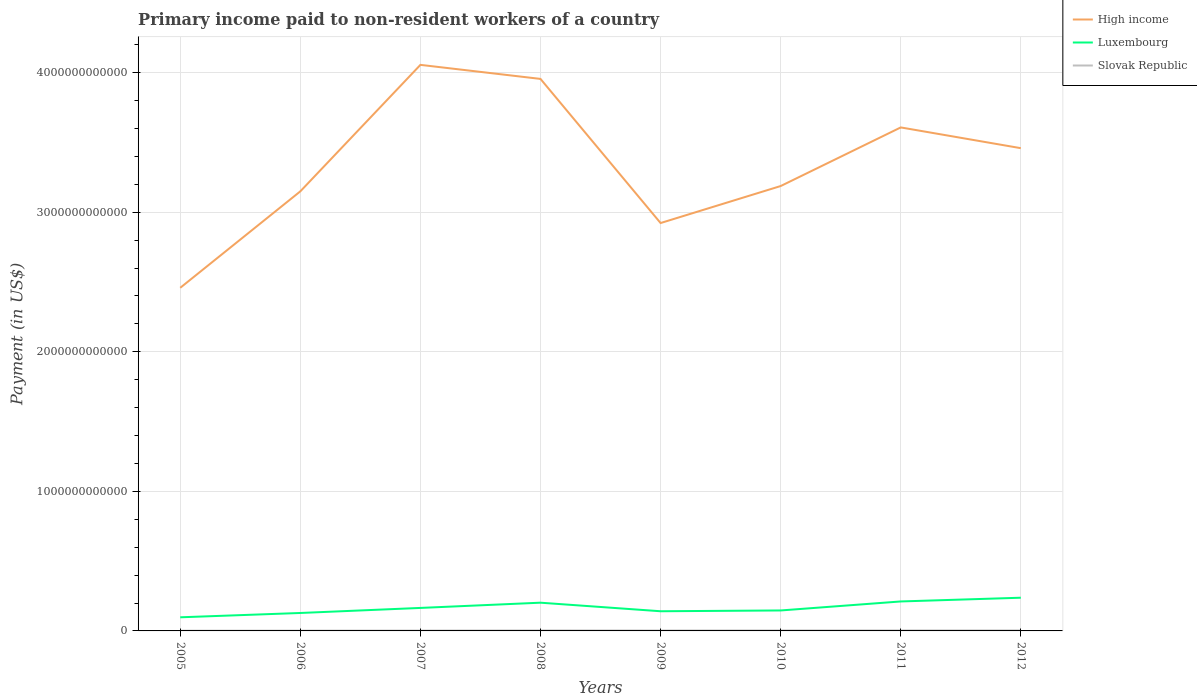Is the number of lines equal to the number of legend labels?
Ensure brevity in your answer.  Yes. Across all years, what is the maximum amount paid to workers in Slovak Republic?
Ensure brevity in your answer.  1.58e+09. What is the total amount paid to workers in Luxembourg in the graph?
Provide a succinct answer. -3.56e+1. What is the difference between the highest and the second highest amount paid to workers in High income?
Ensure brevity in your answer.  1.60e+12. How many years are there in the graph?
Ensure brevity in your answer.  8. What is the difference between two consecutive major ticks on the Y-axis?
Provide a short and direct response. 1.00e+12. Does the graph contain grids?
Give a very brief answer. Yes. What is the title of the graph?
Make the answer very short. Primary income paid to non-resident workers of a country. What is the label or title of the X-axis?
Your response must be concise. Years. What is the label or title of the Y-axis?
Provide a succinct answer. Payment (in US$). What is the Payment (in US$) of High income in 2005?
Offer a terse response. 2.46e+12. What is the Payment (in US$) in Luxembourg in 2005?
Give a very brief answer. 9.77e+1. What is the Payment (in US$) of Slovak Republic in 2005?
Keep it short and to the point. 1.58e+09. What is the Payment (in US$) in High income in 2006?
Provide a short and direct response. 3.15e+12. What is the Payment (in US$) of Luxembourg in 2006?
Provide a succinct answer. 1.29e+11. What is the Payment (in US$) in Slovak Republic in 2006?
Your answer should be very brief. 1.96e+09. What is the Payment (in US$) of High income in 2007?
Make the answer very short. 4.06e+12. What is the Payment (in US$) of Luxembourg in 2007?
Your answer should be very brief. 1.65e+11. What is the Payment (in US$) of Slovak Republic in 2007?
Offer a terse response. 2.34e+09. What is the Payment (in US$) of High income in 2008?
Keep it short and to the point. 3.95e+12. What is the Payment (in US$) in Luxembourg in 2008?
Your answer should be compact. 2.02e+11. What is the Payment (in US$) in Slovak Republic in 2008?
Your answer should be compact. 3.39e+09. What is the Payment (in US$) of High income in 2009?
Keep it short and to the point. 2.92e+12. What is the Payment (in US$) in Luxembourg in 2009?
Provide a succinct answer. 1.41e+11. What is the Payment (in US$) in Slovak Republic in 2009?
Provide a short and direct response. 2.74e+09. What is the Payment (in US$) in High income in 2010?
Your answer should be very brief. 3.19e+12. What is the Payment (in US$) in Luxembourg in 2010?
Keep it short and to the point. 1.47e+11. What is the Payment (in US$) of Slovak Republic in 2010?
Keep it short and to the point. 3.41e+09. What is the Payment (in US$) of High income in 2011?
Keep it short and to the point. 3.61e+12. What is the Payment (in US$) of Luxembourg in 2011?
Give a very brief answer. 2.11e+11. What is the Payment (in US$) of Slovak Republic in 2011?
Your answer should be compact. 3.36e+09. What is the Payment (in US$) in High income in 2012?
Provide a succinct answer. 3.46e+12. What is the Payment (in US$) of Luxembourg in 2012?
Ensure brevity in your answer.  2.38e+11. What is the Payment (in US$) in Slovak Republic in 2012?
Provide a succinct answer. 3.40e+09. Across all years, what is the maximum Payment (in US$) in High income?
Ensure brevity in your answer.  4.06e+12. Across all years, what is the maximum Payment (in US$) of Luxembourg?
Provide a succinct answer. 2.38e+11. Across all years, what is the maximum Payment (in US$) in Slovak Republic?
Your answer should be compact. 3.41e+09. Across all years, what is the minimum Payment (in US$) in High income?
Provide a short and direct response. 2.46e+12. Across all years, what is the minimum Payment (in US$) of Luxembourg?
Ensure brevity in your answer.  9.77e+1. Across all years, what is the minimum Payment (in US$) in Slovak Republic?
Provide a short and direct response. 1.58e+09. What is the total Payment (in US$) of High income in the graph?
Your answer should be compact. 2.68e+13. What is the total Payment (in US$) of Luxembourg in the graph?
Offer a very short reply. 1.33e+12. What is the total Payment (in US$) in Slovak Republic in the graph?
Provide a short and direct response. 2.22e+1. What is the difference between the Payment (in US$) in High income in 2005 and that in 2006?
Your answer should be very brief. -6.91e+11. What is the difference between the Payment (in US$) in Luxembourg in 2005 and that in 2006?
Your response must be concise. -3.09e+1. What is the difference between the Payment (in US$) of Slovak Republic in 2005 and that in 2006?
Offer a very short reply. -3.74e+08. What is the difference between the Payment (in US$) of High income in 2005 and that in 2007?
Provide a succinct answer. -1.60e+12. What is the difference between the Payment (in US$) of Luxembourg in 2005 and that in 2007?
Ensure brevity in your answer.  -6.71e+1. What is the difference between the Payment (in US$) of Slovak Republic in 2005 and that in 2007?
Make the answer very short. -7.55e+08. What is the difference between the Payment (in US$) in High income in 2005 and that in 2008?
Offer a terse response. -1.50e+12. What is the difference between the Payment (in US$) in Luxembourg in 2005 and that in 2008?
Keep it short and to the point. -1.05e+11. What is the difference between the Payment (in US$) in Slovak Republic in 2005 and that in 2008?
Keep it short and to the point. -1.81e+09. What is the difference between the Payment (in US$) in High income in 2005 and that in 2009?
Keep it short and to the point. -4.64e+11. What is the difference between the Payment (in US$) of Luxembourg in 2005 and that in 2009?
Provide a short and direct response. -4.33e+1. What is the difference between the Payment (in US$) of Slovak Republic in 2005 and that in 2009?
Your answer should be very brief. -1.16e+09. What is the difference between the Payment (in US$) of High income in 2005 and that in 2010?
Ensure brevity in your answer.  -7.29e+11. What is the difference between the Payment (in US$) in Luxembourg in 2005 and that in 2010?
Your answer should be compact. -4.89e+1. What is the difference between the Payment (in US$) in Slovak Republic in 2005 and that in 2010?
Give a very brief answer. -1.82e+09. What is the difference between the Payment (in US$) of High income in 2005 and that in 2011?
Your answer should be compact. -1.15e+12. What is the difference between the Payment (in US$) of Luxembourg in 2005 and that in 2011?
Make the answer very short. -1.13e+11. What is the difference between the Payment (in US$) in Slovak Republic in 2005 and that in 2011?
Your response must be concise. -1.78e+09. What is the difference between the Payment (in US$) in High income in 2005 and that in 2012?
Provide a succinct answer. -1.00e+12. What is the difference between the Payment (in US$) in Luxembourg in 2005 and that in 2012?
Provide a succinct answer. -1.40e+11. What is the difference between the Payment (in US$) in Slovak Republic in 2005 and that in 2012?
Make the answer very short. -1.82e+09. What is the difference between the Payment (in US$) in High income in 2006 and that in 2007?
Provide a succinct answer. -9.06e+11. What is the difference between the Payment (in US$) of Luxembourg in 2006 and that in 2007?
Offer a very short reply. -3.62e+1. What is the difference between the Payment (in US$) of Slovak Republic in 2006 and that in 2007?
Provide a succinct answer. -3.81e+08. What is the difference between the Payment (in US$) of High income in 2006 and that in 2008?
Offer a terse response. -8.06e+11. What is the difference between the Payment (in US$) in Luxembourg in 2006 and that in 2008?
Make the answer very short. -7.37e+1. What is the difference between the Payment (in US$) of Slovak Republic in 2006 and that in 2008?
Keep it short and to the point. -1.43e+09. What is the difference between the Payment (in US$) in High income in 2006 and that in 2009?
Your answer should be compact. 2.27e+11. What is the difference between the Payment (in US$) in Luxembourg in 2006 and that in 2009?
Provide a short and direct response. -1.24e+1. What is the difference between the Payment (in US$) of Slovak Republic in 2006 and that in 2009?
Keep it short and to the point. -7.85e+08. What is the difference between the Payment (in US$) in High income in 2006 and that in 2010?
Your response must be concise. -3.80e+1. What is the difference between the Payment (in US$) of Luxembourg in 2006 and that in 2010?
Your answer should be compact. -1.80e+1. What is the difference between the Payment (in US$) of Slovak Republic in 2006 and that in 2010?
Your response must be concise. -1.45e+09. What is the difference between the Payment (in US$) of High income in 2006 and that in 2011?
Give a very brief answer. -4.58e+11. What is the difference between the Payment (in US$) of Luxembourg in 2006 and that in 2011?
Offer a very short reply. -8.26e+1. What is the difference between the Payment (in US$) of Slovak Republic in 2006 and that in 2011?
Offer a very short reply. -1.40e+09. What is the difference between the Payment (in US$) in High income in 2006 and that in 2012?
Give a very brief answer. -3.09e+11. What is the difference between the Payment (in US$) of Luxembourg in 2006 and that in 2012?
Make the answer very short. -1.09e+11. What is the difference between the Payment (in US$) in Slovak Republic in 2006 and that in 2012?
Your answer should be compact. -1.44e+09. What is the difference between the Payment (in US$) of High income in 2007 and that in 2008?
Offer a very short reply. 1.01e+11. What is the difference between the Payment (in US$) of Luxembourg in 2007 and that in 2008?
Your response must be concise. -3.75e+1. What is the difference between the Payment (in US$) of Slovak Republic in 2007 and that in 2008?
Provide a succinct answer. -1.05e+09. What is the difference between the Payment (in US$) in High income in 2007 and that in 2009?
Provide a succinct answer. 1.13e+12. What is the difference between the Payment (in US$) in Luxembourg in 2007 and that in 2009?
Your answer should be compact. 2.38e+1. What is the difference between the Payment (in US$) in Slovak Republic in 2007 and that in 2009?
Your answer should be very brief. -4.04e+08. What is the difference between the Payment (in US$) of High income in 2007 and that in 2010?
Offer a very short reply. 8.68e+11. What is the difference between the Payment (in US$) of Luxembourg in 2007 and that in 2010?
Your answer should be compact. 1.82e+1. What is the difference between the Payment (in US$) of Slovak Republic in 2007 and that in 2010?
Keep it short and to the point. -1.07e+09. What is the difference between the Payment (in US$) of High income in 2007 and that in 2011?
Your response must be concise. 4.48e+11. What is the difference between the Payment (in US$) in Luxembourg in 2007 and that in 2011?
Your answer should be very brief. -4.64e+1. What is the difference between the Payment (in US$) in Slovak Republic in 2007 and that in 2011?
Your response must be concise. -1.02e+09. What is the difference between the Payment (in US$) in High income in 2007 and that in 2012?
Provide a short and direct response. 5.97e+11. What is the difference between the Payment (in US$) in Luxembourg in 2007 and that in 2012?
Provide a succinct answer. -7.31e+1. What is the difference between the Payment (in US$) of Slovak Republic in 2007 and that in 2012?
Your answer should be compact. -1.06e+09. What is the difference between the Payment (in US$) in High income in 2008 and that in 2009?
Offer a terse response. 1.03e+12. What is the difference between the Payment (in US$) in Luxembourg in 2008 and that in 2009?
Offer a very short reply. 6.13e+1. What is the difference between the Payment (in US$) of Slovak Republic in 2008 and that in 2009?
Provide a short and direct response. 6.49e+08. What is the difference between the Payment (in US$) in High income in 2008 and that in 2010?
Your response must be concise. 7.68e+11. What is the difference between the Payment (in US$) in Luxembourg in 2008 and that in 2010?
Provide a succinct answer. 5.56e+1. What is the difference between the Payment (in US$) in Slovak Republic in 2008 and that in 2010?
Give a very brief answer. -1.33e+07. What is the difference between the Payment (in US$) in High income in 2008 and that in 2011?
Offer a terse response. 3.48e+11. What is the difference between the Payment (in US$) in Luxembourg in 2008 and that in 2011?
Offer a very short reply. -8.90e+09. What is the difference between the Payment (in US$) in Slovak Republic in 2008 and that in 2011?
Provide a succinct answer. 2.89e+07. What is the difference between the Payment (in US$) of High income in 2008 and that in 2012?
Ensure brevity in your answer.  4.96e+11. What is the difference between the Payment (in US$) in Luxembourg in 2008 and that in 2012?
Offer a very short reply. -3.56e+1. What is the difference between the Payment (in US$) of Slovak Republic in 2008 and that in 2012?
Ensure brevity in your answer.  -1.11e+07. What is the difference between the Payment (in US$) of High income in 2009 and that in 2010?
Provide a short and direct response. -2.65e+11. What is the difference between the Payment (in US$) in Luxembourg in 2009 and that in 2010?
Keep it short and to the point. -5.64e+09. What is the difference between the Payment (in US$) of Slovak Republic in 2009 and that in 2010?
Ensure brevity in your answer.  -6.62e+08. What is the difference between the Payment (in US$) in High income in 2009 and that in 2011?
Provide a succinct answer. -6.85e+11. What is the difference between the Payment (in US$) in Luxembourg in 2009 and that in 2011?
Your answer should be compact. -7.02e+1. What is the difference between the Payment (in US$) in Slovak Republic in 2009 and that in 2011?
Your response must be concise. -6.20e+08. What is the difference between the Payment (in US$) in High income in 2009 and that in 2012?
Offer a terse response. -5.36e+11. What is the difference between the Payment (in US$) of Luxembourg in 2009 and that in 2012?
Ensure brevity in your answer.  -9.69e+1. What is the difference between the Payment (in US$) in Slovak Republic in 2009 and that in 2012?
Keep it short and to the point. -6.60e+08. What is the difference between the Payment (in US$) of High income in 2010 and that in 2011?
Provide a short and direct response. -4.20e+11. What is the difference between the Payment (in US$) in Luxembourg in 2010 and that in 2011?
Keep it short and to the point. -6.46e+1. What is the difference between the Payment (in US$) of Slovak Republic in 2010 and that in 2011?
Your answer should be very brief. 4.22e+07. What is the difference between the Payment (in US$) in High income in 2010 and that in 2012?
Make the answer very short. -2.71e+11. What is the difference between the Payment (in US$) of Luxembourg in 2010 and that in 2012?
Keep it short and to the point. -9.12e+1. What is the difference between the Payment (in US$) of Slovak Republic in 2010 and that in 2012?
Ensure brevity in your answer.  2.24e+06. What is the difference between the Payment (in US$) of High income in 2011 and that in 2012?
Make the answer very short. 1.49e+11. What is the difference between the Payment (in US$) of Luxembourg in 2011 and that in 2012?
Offer a terse response. -2.67e+1. What is the difference between the Payment (in US$) of Slovak Republic in 2011 and that in 2012?
Offer a very short reply. -4.00e+07. What is the difference between the Payment (in US$) of High income in 2005 and the Payment (in US$) of Luxembourg in 2006?
Your response must be concise. 2.33e+12. What is the difference between the Payment (in US$) in High income in 2005 and the Payment (in US$) in Slovak Republic in 2006?
Offer a terse response. 2.46e+12. What is the difference between the Payment (in US$) in Luxembourg in 2005 and the Payment (in US$) in Slovak Republic in 2006?
Keep it short and to the point. 9.57e+1. What is the difference between the Payment (in US$) of High income in 2005 and the Payment (in US$) of Luxembourg in 2007?
Provide a succinct answer. 2.29e+12. What is the difference between the Payment (in US$) of High income in 2005 and the Payment (in US$) of Slovak Republic in 2007?
Your answer should be compact. 2.46e+12. What is the difference between the Payment (in US$) in Luxembourg in 2005 and the Payment (in US$) in Slovak Republic in 2007?
Give a very brief answer. 9.53e+1. What is the difference between the Payment (in US$) in High income in 2005 and the Payment (in US$) in Luxembourg in 2008?
Offer a terse response. 2.26e+12. What is the difference between the Payment (in US$) of High income in 2005 and the Payment (in US$) of Slovak Republic in 2008?
Offer a terse response. 2.45e+12. What is the difference between the Payment (in US$) in Luxembourg in 2005 and the Payment (in US$) in Slovak Republic in 2008?
Ensure brevity in your answer.  9.43e+1. What is the difference between the Payment (in US$) of High income in 2005 and the Payment (in US$) of Luxembourg in 2009?
Offer a very short reply. 2.32e+12. What is the difference between the Payment (in US$) of High income in 2005 and the Payment (in US$) of Slovak Republic in 2009?
Provide a short and direct response. 2.46e+12. What is the difference between the Payment (in US$) in Luxembourg in 2005 and the Payment (in US$) in Slovak Republic in 2009?
Your response must be concise. 9.49e+1. What is the difference between the Payment (in US$) in High income in 2005 and the Payment (in US$) in Luxembourg in 2010?
Keep it short and to the point. 2.31e+12. What is the difference between the Payment (in US$) in High income in 2005 and the Payment (in US$) in Slovak Republic in 2010?
Offer a terse response. 2.45e+12. What is the difference between the Payment (in US$) in Luxembourg in 2005 and the Payment (in US$) in Slovak Republic in 2010?
Your answer should be compact. 9.43e+1. What is the difference between the Payment (in US$) in High income in 2005 and the Payment (in US$) in Luxembourg in 2011?
Make the answer very short. 2.25e+12. What is the difference between the Payment (in US$) of High income in 2005 and the Payment (in US$) of Slovak Republic in 2011?
Make the answer very short. 2.45e+12. What is the difference between the Payment (in US$) of Luxembourg in 2005 and the Payment (in US$) of Slovak Republic in 2011?
Make the answer very short. 9.43e+1. What is the difference between the Payment (in US$) in High income in 2005 and the Payment (in US$) in Luxembourg in 2012?
Ensure brevity in your answer.  2.22e+12. What is the difference between the Payment (in US$) in High income in 2005 and the Payment (in US$) in Slovak Republic in 2012?
Provide a succinct answer. 2.45e+12. What is the difference between the Payment (in US$) in Luxembourg in 2005 and the Payment (in US$) in Slovak Republic in 2012?
Offer a terse response. 9.43e+1. What is the difference between the Payment (in US$) in High income in 2006 and the Payment (in US$) in Luxembourg in 2007?
Give a very brief answer. 2.98e+12. What is the difference between the Payment (in US$) in High income in 2006 and the Payment (in US$) in Slovak Republic in 2007?
Give a very brief answer. 3.15e+12. What is the difference between the Payment (in US$) in Luxembourg in 2006 and the Payment (in US$) in Slovak Republic in 2007?
Your answer should be very brief. 1.26e+11. What is the difference between the Payment (in US$) in High income in 2006 and the Payment (in US$) in Luxembourg in 2008?
Your answer should be compact. 2.95e+12. What is the difference between the Payment (in US$) in High income in 2006 and the Payment (in US$) in Slovak Republic in 2008?
Ensure brevity in your answer.  3.15e+12. What is the difference between the Payment (in US$) of Luxembourg in 2006 and the Payment (in US$) of Slovak Republic in 2008?
Your answer should be very brief. 1.25e+11. What is the difference between the Payment (in US$) of High income in 2006 and the Payment (in US$) of Luxembourg in 2009?
Keep it short and to the point. 3.01e+12. What is the difference between the Payment (in US$) in High income in 2006 and the Payment (in US$) in Slovak Republic in 2009?
Your answer should be very brief. 3.15e+12. What is the difference between the Payment (in US$) of Luxembourg in 2006 and the Payment (in US$) of Slovak Republic in 2009?
Provide a short and direct response. 1.26e+11. What is the difference between the Payment (in US$) in High income in 2006 and the Payment (in US$) in Luxembourg in 2010?
Your response must be concise. 3.00e+12. What is the difference between the Payment (in US$) of High income in 2006 and the Payment (in US$) of Slovak Republic in 2010?
Provide a succinct answer. 3.15e+12. What is the difference between the Payment (in US$) in Luxembourg in 2006 and the Payment (in US$) in Slovak Republic in 2010?
Provide a succinct answer. 1.25e+11. What is the difference between the Payment (in US$) in High income in 2006 and the Payment (in US$) in Luxembourg in 2011?
Give a very brief answer. 2.94e+12. What is the difference between the Payment (in US$) in High income in 2006 and the Payment (in US$) in Slovak Republic in 2011?
Make the answer very short. 3.15e+12. What is the difference between the Payment (in US$) of Luxembourg in 2006 and the Payment (in US$) of Slovak Republic in 2011?
Provide a succinct answer. 1.25e+11. What is the difference between the Payment (in US$) in High income in 2006 and the Payment (in US$) in Luxembourg in 2012?
Your response must be concise. 2.91e+12. What is the difference between the Payment (in US$) in High income in 2006 and the Payment (in US$) in Slovak Republic in 2012?
Your answer should be compact. 3.15e+12. What is the difference between the Payment (in US$) of Luxembourg in 2006 and the Payment (in US$) of Slovak Republic in 2012?
Ensure brevity in your answer.  1.25e+11. What is the difference between the Payment (in US$) of High income in 2007 and the Payment (in US$) of Luxembourg in 2008?
Keep it short and to the point. 3.85e+12. What is the difference between the Payment (in US$) of High income in 2007 and the Payment (in US$) of Slovak Republic in 2008?
Your answer should be very brief. 4.05e+12. What is the difference between the Payment (in US$) of Luxembourg in 2007 and the Payment (in US$) of Slovak Republic in 2008?
Offer a terse response. 1.61e+11. What is the difference between the Payment (in US$) in High income in 2007 and the Payment (in US$) in Luxembourg in 2009?
Make the answer very short. 3.91e+12. What is the difference between the Payment (in US$) in High income in 2007 and the Payment (in US$) in Slovak Republic in 2009?
Offer a terse response. 4.05e+12. What is the difference between the Payment (in US$) of Luxembourg in 2007 and the Payment (in US$) of Slovak Republic in 2009?
Your response must be concise. 1.62e+11. What is the difference between the Payment (in US$) in High income in 2007 and the Payment (in US$) in Luxembourg in 2010?
Provide a short and direct response. 3.91e+12. What is the difference between the Payment (in US$) of High income in 2007 and the Payment (in US$) of Slovak Republic in 2010?
Offer a terse response. 4.05e+12. What is the difference between the Payment (in US$) of Luxembourg in 2007 and the Payment (in US$) of Slovak Republic in 2010?
Your response must be concise. 1.61e+11. What is the difference between the Payment (in US$) in High income in 2007 and the Payment (in US$) in Luxembourg in 2011?
Provide a short and direct response. 3.84e+12. What is the difference between the Payment (in US$) of High income in 2007 and the Payment (in US$) of Slovak Republic in 2011?
Ensure brevity in your answer.  4.05e+12. What is the difference between the Payment (in US$) in Luxembourg in 2007 and the Payment (in US$) in Slovak Republic in 2011?
Your answer should be compact. 1.61e+11. What is the difference between the Payment (in US$) of High income in 2007 and the Payment (in US$) of Luxembourg in 2012?
Make the answer very short. 3.82e+12. What is the difference between the Payment (in US$) of High income in 2007 and the Payment (in US$) of Slovak Republic in 2012?
Ensure brevity in your answer.  4.05e+12. What is the difference between the Payment (in US$) of Luxembourg in 2007 and the Payment (in US$) of Slovak Republic in 2012?
Offer a terse response. 1.61e+11. What is the difference between the Payment (in US$) in High income in 2008 and the Payment (in US$) in Luxembourg in 2009?
Your answer should be very brief. 3.81e+12. What is the difference between the Payment (in US$) in High income in 2008 and the Payment (in US$) in Slovak Republic in 2009?
Your answer should be compact. 3.95e+12. What is the difference between the Payment (in US$) in Luxembourg in 2008 and the Payment (in US$) in Slovak Republic in 2009?
Offer a very short reply. 1.99e+11. What is the difference between the Payment (in US$) of High income in 2008 and the Payment (in US$) of Luxembourg in 2010?
Make the answer very short. 3.81e+12. What is the difference between the Payment (in US$) of High income in 2008 and the Payment (in US$) of Slovak Republic in 2010?
Ensure brevity in your answer.  3.95e+12. What is the difference between the Payment (in US$) in Luxembourg in 2008 and the Payment (in US$) in Slovak Republic in 2010?
Keep it short and to the point. 1.99e+11. What is the difference between the Payment (in US$) in High income in 2008 and the Payment (in US$) in Luxembourg in 2011?
Provide a short and direct response. 3.74e+12. What is the difference between the Payment (in US$) in High income in 2008 and the Payment (in US$) in Slovak Republic in 2011?
Give a very brief answer. 3.95e+12. What is the difference between the Payment (in US$) in Luxembourg in 2008 and the Payment (in US$) in Slovak Republic in 2011?
Your answer should be compact. 1.99e+11. What is the difference between the Payment (in US$) of High income in 2008 and the Payment (in US$) of Luxembourg in 2012?
Give a very brief answer. 3.72e+12. What is the difference between the Payment (in US$) of High income in 2008 and the Payment (in US$) of Slovak Republic in 2012?
Offer a very short reply. 3.95e+12. What is the difference between the Payment (in US$) of Luxembourg in 2008 and the Payment (in US$) of Slovak Republic in 2012?
Keep it short and to the point. 1.99e+11. What is the difference between the Payment (in US$) in High income in 2009 and the Payment (in US$) in Luxembourg in 2010?
Your response must be concise. 2.78e+12. What is the difference between the Payment (in US$) of High income in 2009 and the Payment (in US$) of Slovak Republic in 2010?
Make the answer very short. 2.92e+12. What is the difference between the Payment (in US$) in Luxembourg in 2009 and the Payment (in US$) in Slovak Republic in 2010?
Keep it short and to the point. 1.38e+11. What is the difference between the Payment (in US$) in High income in 2009 and the Payment (in US$) in Luxembourg in 2011?
Offer a terse response. 2.71e+12. What is the difference between the Payment (in US$) of High income in 2009 and the Payment (in US$) of Slovak Republic in 2011?
Your answer should be compact. 2.92e+12. What is the difference between the Payment (in US$) of Luxembourg in 2009 and the Payment (in US$) of Slovak Republic in 2011?
Your answer should be very brief. 1.38e+11. What is the difference between the Payment (in US$) in High income in 2009 and the Payment (in US$) in Luxembourg in 2012?
Offer a terse response. 2.68e+12. What is the difference between the Payment (in US$) of High income in 2009 and the Payment (in US$) of Slovak Republic in 2012?
Your answer should be very brief. 2.92e+12. What is the difference between the Payment (in US$) in Luxembourg in 2009 and the Payment (in US$) in Slovak Republic in 2012?
Your answer should be very brief. 1.38e+11. What is the difference between the Payment (in US$) of High income in 2010 and the Payment (in US$) of Luxembourg in 2011?
Your answer should be compact. 2.98e+12. What is the difference between the Payment (in US$) of High income in 2010 and the Payment (in US$) of Slovak Republic in 2011?
Your answer should be very brief. 3.18e+12. What is the difference between the Payment (in US$) of Luxembourg in 2010 and the Payment (in US$) of Slovak Republic in 2011?
Provide a short and direct response. 1.43e+11. What is the difference between the Payment (in US$) in High income in 2010 and the Payment (in US$) in Luxembourg in 2012?
Offer a very short reply. 2.95e+12. What is the difference between the Payment (in US$) in High income in 2010 and the Payment (in US$) in Slovak Republic in 2012?
Your answer should be compact. 3.18e+12. What is the difference between the Payment (in US$) of Luxembourg in 2010 and the Payment (in US$) of Slovak Republic in 2012?
Give a very brief answer. 1.43e+11. What is the difference between the Payment (in US$) in High income in 2011 and the Payment (in US$) in Luxembourg in 2012?
Ensure brevity in your answer.  3.37e+12. What is the difference between the Payment (in US$) in High income in 2011 and the Payment (in US$) in Slovak Republic in 2012?
Give a very brief answer. 3.60e+12. What is the difference between the Payment (in US$) in Luxembourg in 2011 and the Payment (in US$) in Slovak Republic in 2012?
Offer a terse response. 2.08e+11. What is the average Payment (in US$) in High income per year?
Ensure brevity in your answer.  3.35e+12. What is the average Payment (in US$) in Luxembourg per year?
Offer a very short reply. 1.66e+11. What is the average Payment (in US$) in Slovak Republic per year?
Offer a very short reply. 2.77e+09. In the year 2005, what is the difference between the Payment (in US$) in High income and Payment (in US$) in Luxembourg?
Ensure brevity in your answer.  2.36e+12. In the year 2005, what is the difference between the Payment (in US$) in High income and Payment (in US$) in Slovak Republic?
Offer a very short reply. 2.46e+12. In the year 2005, what is the difference between the Payment (in US$) in Luxembourg and Payment (in US$) in Slovak Republic?
Your answer should be very brief. 9.61e+1. In the year 2006, what is the difference between the Payment (in US$) in High income and Payment (in US$) in Luxembourg?
Ensure brevity in your answer.  3.02e+12. In the year 2006, what is the difference between the Payment (in US$) of High income and Payment (in US$) of Slovak Republic?
Ensure brevity in your answer.  3.15e+12. In the year 2006, what is the difference between the Payment (in US$) in Luxembourg and Payment (in US$) in Slovak Republic?
Your answer should be very brief. 1.27e+11. In the year 2007, what is the difference between the Payment (in US$) of High income and Payment (in US$) of Luxembourg?
Offer a terse response. 3.89e+12. In the year 2007, what is the difference between the Payment (in US$) in High income and Payment (in US$) in Slovak Republic?
Ensure brevity in your answer.  4.05e+12. In the year 2007, what is the difference between the Payment (in US$) in Luxembourg and Payment (in US$) in Slovak Republic?
Provide a short and direct response. 1.62e+11. In the year 2008, what is the difference between the Payment (in US$) of High income and Payment (in US$) of Luxembourg?
Ensure brevity in your answer.  3.75e+12. In the year 2008, what is the difference between the Payment (in US$) of High income and Payment (in US$) of Slovak Republic?
Provide a short and direct response. 3.95e+12. In the year 2008, what is the difference between the Payment (in US$) of Luxembourg and Payment (in US$) of Slovak Republic?
Ensure brevity in your answer.  1.99e+11. In the year 2009, what is the difference between the Payment (in US$) of High income and Payment (in US$) of Luxembourg?
Your answer should be very brief. 2.78e+12. In the year 2009, what is the difference between the Payment (in US$) in High income and Payment (in US$) in Slovak Republic?
Give a very brief answer. 2.92e+12. In the year 2009, what is the difference between the Payment (in US$) of Luxembourg and Payment (in US$) of Slovak Republic?
Keep it short and to the point. 1.38e+11. In the year 2010, what is the difference between the Payment (in US$) in High income and Payment (in US$) in Luxembourg?
Provide a succinct answer. 3.04e+12. In the year 2010, what is the difference between the Payment (in US$) of High income and Payment (in US$) of Slovak Republic?
Give a very brief answer. 3.18e+12. In the year 2010, what is the difference between the Payment (in US$) of Luxembourg and Payment (in US$) of Slovak Republic?
Provide a succinct answer. 1.43e+11. In the year 2011, what is the difference between the Payment (in US$) in High income and Payment (in US$) in Luxembourg?
Offer a very short reply. 3.40e+12. In the year 2011, what is the difference between the Payment (in US$) in High income and Payment (in US$) in Slovak Republic?
Give a very brief answer. 3.60e+12. In the year 2011, what is the difference between the Payment (in US$) of Luxembourg and Payment (in US$) of Slovak Republic?
Offer a terse response. 2.08e+11. In the year 2012, what is the difference between the Payment (in US$) in High income and Payment (in US$) in Luxembourg?
Offer a terse response. 3.22e+12. In the year 2012, what is the difference between the Payment (in US$) in High income and Payment (in US$) in Slovak Republic?
Your answer should be compact. 3.46e+12. In the year 2012, what is the difference between the Payment (in US$) in Luxembourg and Payment (in US$) in Slovak Republic?
Offer a very short reply. 2.34e+11. What is the ratio of the Payment (in US$) of High income in 2005 to that in 2006?
Make the answer very short. 0.78. What is the ratio of the Payment (in US$) in Luxembourg in 2005 to that in 2006?
Give a very brief answer. 0.76. What is the ratio of the Payment (in US$) in Slovak Republic in 2005 to that in 2006?
Offer a terse response. 0.81. What is the ratio of the Payment (in US$) in High income in 2005 to that in 2007?
Ensure brevity in your answer.  0.61. What is the ratio of the Payment (in US$) in Luxembourg in 2005 to that in 2007?
Your answer should be compact. 0.59. What is the ratio of the Payment (in US$) of Slovak Republic in 2005 to that in 2007?
Your answer should be compact. 0.68. What is the ratio of the Payment (in US$) in High income in 2005 to that in 2008?
Offer a terse response. 0.62. What is the ratio of the Payment (in US$) of Luxembourg in 2005 to that in 2008?
Your response must be concise. 0.48. What is the ratio of the Payment (in US$) in Slovak Republic in 2005 to that in 2008?
Offer a terse response. 0.47. What is the ratio of the Payment (in US$) in High income in 2005 to that in 2009?
Make the answer very short. 0.84. What is the ratio of the Payment (in US$) of Luxembourg in 2005 to that in 2009?
Your answer should be compact. 0.69. What is the ratio of the Payment (in US$) in Slovak Republic in 2005 to that in 2009?
Ensure brevity in your answer.  0.58. What is the ratio of the Payment (in US$) in High income in 2005 to that in 2010?
Provide a succinct answer. 0.77. What is the ratio of the Payment (in US$) in Luxembourg in 2005 to that in 2010?
Provide a succinct answer. 0.67. What is the ratio of the Payment (in US$) of Slovak Republic in 2005 to that in 2010?
Give a very brief answer. 0.47. What is the ratio of the Payment (in US$) in High income in 2005 to that in 2011?
Your answer should be compact. 0.68. What is the ratio of the Payment (in US$) of Luxembourg in 2005 to that in 2011?
Give a very brief answer. 0.46. What is the ratio of the Payment (in US$) of Slovak Republic in 2005 to that in 2011?
Provide a succinct answer. 0.47. What is the ratio of the Payment (in US$) of High income in 2005 to that in 2012?
Your response must be concise. 0.71. What is the ratio of the Payment (in US$) in Luxembourg in 2005 to that in 2012?
Give a very brief answer. 0.41. What is the ratio of the Payment (in US$) in Slovak Republic in 2005 to that in 2012?
Ensure brevity in your answer.  0.47. What is the ratio of the Payment (in US$) of High income in 2006 to that in 2007?
Offer a very short reply. 0.78. What is the ratio of the Payment (in US$) of Luxembourg in 2006 to that in 2007?
Your answer should be compact. 0.78. What is the ratio of the Payment (in US$) in Slovak Republic in 2006 to that in 2007?
Provide a short and direct response. 0.84. What is the ratio of the Payment (in US$) of High income in 2006 to that in 2008?
Provide a short and direct response. 0.8. What is the ratio of the Payment (in US$) in Luxembourg in 2006 to that in 2008?
Provide a short and direct response. 0.64. What is the ratio of the Payment (in US$) in Slovak Republic in 2006 to that in 2008?
Make the answer very short. 0.58. What is the ratio of the Payment (in US$) of High income in 2006 to that in 2009?
Your response must be concise. 1.08. What is the ratio of the Payment (in US$) of Luxembourg in 2006 to that in 2009?
Your answer should be very brief. 0.91. What is the ratio of the Payment (in US$) of Slovak Republic in 2006 to that in 2009?
Provide a short and direct response. 0.71. What is the ratio of the Payment (in US$) of Luxembourg in 2006 to that in 2010?
Your answer should be compact. 0.88. What is the ratio of the Payment (in US$) in Slovak Republic in 2006 to that in 2010?
Provide a succinct answer. 0.58. What is the ratio of the Payment (in US$) of High income in 2006 to that in 2011?
Your answer should be very brief. 0.87. What is the ratio of the Payment (in US$) in Luxembourg in 2006 to that in 2011?
Offer a terse response. 0.61. What is the ratio of the Payment (in US$) in Slovak Republic in 2006 to that in 2011?
Keep it short and to the point. 0.58. What is the ratio of the Payment (in US$) in High income in 2006 to that in 2012?
Ensure brevity in your answer.  0.91. What is the ratio of the Payment (in US$) of Luxembourg in 2006 to that in 2012?
Offer a very short reply. 0.54. What is the ratio of the Payment (in US$) in Slovak Republic in 2006 to that in 2012?
Ensure brevity in your answer.  0.58. What is the ratio of the Payment (in US$) in High income in 2007 to that in 2008?
Ensure brevity in your answer.  1.03. What is the ratio of the Payment (in US$) in Luxembourg in 2007 to that in 2008?
Offer a terse response. 0.81. What is the ratio of the Payment (in US$) of Slovak Republic in 2007 to that in 2008?
Provide a succinct answer. 0.69. What is the ratio of the Payment (in US$) in High income in 2007 to that in 2009?
Your answer should be compact. 1.39. What is the ratio of the Payment (in US$) of Luxembourg in 2007 to that in 2009?
Provide a short and direct response. 1.17. What is the ratio of the Payment (in US$) of Slovak Republic in 2007 to that in 2009?
Ensure brevity in your answer.  0.85. What is the ratio of the Payment (in US$) of High income in 2007 to that in 2010?
Make the answer very short. 1.27. What is the ratio of the Payment (in US$) in Luxembourg in 2007 to that in 2010?
Ensure brevity in your answer.  1.12. What is the ratio of the Payment (in US$) of Slovak Republic in 2007 to that in 2010?
Keep it short and to the point. 0.69. What is the ratio of the Payment (in US$) of High income in 2007 to that in 2011?
Offer a terse response. 1.12. What is the ratio of the Payment (in US$) of Luxembourg in 2007 to that in 2011?
Keep it short and to the point. 0.78. What is the ratio of the Payment (in US$) in Slovak Republic in 2007 to that in 2011?
Ensure brevity in your answer.  0.7. What is the ratio of the Payment (in US$) in High income in 2007 to that in 2012?
Make the answer very short. 1.17. What is the ratio of the Payment (in US$) in Luxembourg in 2007 to that in 2012?
Give a very brief answer. 0.69. What is the ratio of the Payment (in US$) in Slovak Republic in 2007 to that in 2012?
Offer a very short reply. 0.69. What is the ratio of the Payment (in US$) in High income in 2008 to that in 2009?
Provide a short and direct response. 1.35. What is the ratio of the Payment (in US$) of Luxembourg in 2008 to that in 2009?
Keep it short and to the point. 1.43. What is the ratio of the Payment (in US$) of Slovak Republic in 2008 to that in 2009?
Offer a terse response. 1.24. What is the ratio of the Payment (in US$) in High income in 2008 to that in 2010?
Keep it short and to the point. 1.24. What is the ratio of the Payment (in US$) in Luxembourg in 2008 to that in 2010?
Ensure brevity in your answer.  1.38. What is the ratio of the Payment (in US$) of High income in 2008 to that in 2011?
Your answer should be very brief. 1.1. What is the ratio of the Payment (in US$) of Luxembourg in 2008 to that in 2011?
Your response must be concise. 0.96. What is the ratio of the Payment (in US$) in Slovak Republic in 2008 to that in 2011?
Provide a short and direct response. 1.01. What is the ratio of the Payment (in US$) of High income in 2008 to that in 2012?
Your response must be concise. 1.14. What is the ratio of the Payment (in US$) in Luxembourg in 2008 to that in 2012?
Provide a succinct answer. 0.85. What is the ratio of the Payment (in US$) of Slovak Republic in 2008 to that in 2012?
Offer a terse response. 1. What is the ratio of the Payment (in US$) of High income in 2009 to that in 2010?
Provide a succinct answer. 0.92. What is the ratio of the Payment (in US$) of Luxembourg in 2009 to that in 2010?
Your response must be concise. 0.96. What is the ratio of the Payment (in US$) of Slovak Republic in 2009 to that in 2010?
Keep it short and to the point. 0.81. What is the ratio of the Payment (in US$) of High income in 2009 to that in 2011?
Your response must be concise. 0.81. What is the ratio of the Payment (in US$) in Luxembourg in 2009 to that in 2011?
Keep it short and to the point. 0.67. What is the ratio of the Payment (in US$) in Slovak Republic in 2009 to that in 2011?
Provide a succinct answer. 0.82. What is the ratio of the Payment (in US$) of High income in 2009 to that in 2012?
Provide a succinct answer. 0.84. What is the ratio of the Payment (in US$) in Luxembourg in 2009 to that in 2012?
Your answer should be compact. 0.59. What is the ratio of the Payment (in US$) in Slovak Republic in 2009 to that in 2012?
Ensure brevity in your answer.  0.81. What is the ratio of the Payment (in US$) of High income in 2010 to that in 2011?
Your answer should be very brief. 0.88. What is the ratio of the Payment (in US$) in Luxembourg in 2010 to that in 2011?
Your answer should be very brief. 0.69. What is the ratio of the Payment (in US$) of Slovak Republic in 2010 to that in 2011?
Your response must be concise. 1.01. What is the ratio of the Payment (in US$) of High income in 2010 to that in 2012?
Your answer should be compact. 0.92. What is the ratio of the Payment (in US$) of Luxembourg in 2010 to that in 2012?
Ensure brevity in your answer.  0.62. What is the ratio of the Payment (in US$) in Slovak Republic in 2010 to that in 2012?
Offer a very short reply. 1. What is the ratio of the Payment (in US$) in High income in 2011 to that in 2012?
Your answer should be compact. 1.04. What is the ratio of the Payment (in US$) of Luxembourg in 2011 to that in 2012?
Make the answer very short. 0.89. What is the ratio of the Payment (in US$) of Slovak Republic in 2011 to that in 2012?
Your answer should be very brief. 0.99. What is the difference between the highest and the second highest Payment (in US$) in High income?
Provide a short and direct response. 1.01e+11. What is the difference between the highest and the second highest Payment (in US$) in Luxembourg?
Offer a very short reply. 2.67e+1. What is the difference between the highest and the second highest Payment (in US$) in Slovak Republic?
Provide a succinct answer. 2.24e+06. What is the difference between the highest and the lowest Payment (in US$) in High income?
Your answer should be very brief. 1.60e+12. What is the difference between the highest and the lowest Payment (in US$) in Luxembourg?
Your answer should be very brief. 1.40e+11. What is the difference between the highest and the lowest Payment (in US$) in Slovak Republic?
Ensure brevity in your answer.  1.82e+09. 